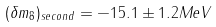<formula> <loc_0><loc_0><loc_500><loc_500>( \delta m _ { 8 } ) _ { s e c o n d } = - 1 5 . 1 \pm 1 . 2 M e V</formula> 